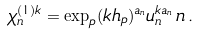Convert formula to latex. <formula><loc_0><loc_0><loc_500><loc_500>\chi ^ { ( 1 ) k } _ { n } = \exp _ { p } ( k h _ { p } ) ^ { a _ { n } } u ^ { k a _ { n } } _ { n } \, n \, .</formula> 